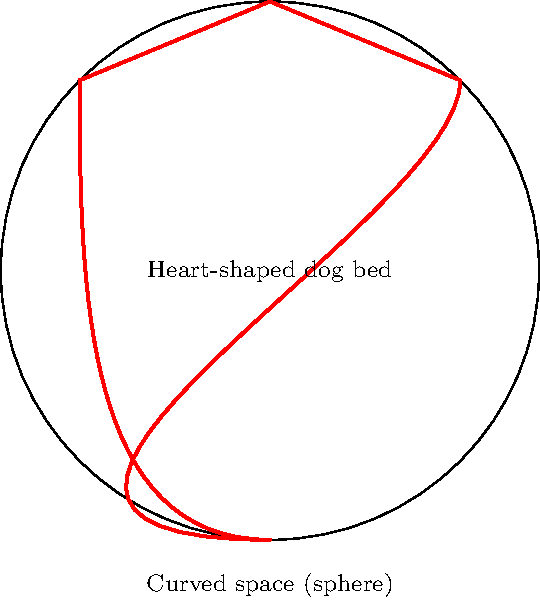On a spherical planet with radius $R$, a heart-shaped dog bed is placed on its surface. The bed's outline is formed by two circular arcs meeting at a point at the top of the heart, and the width of the bed at its widest point is $\frac{\pi R}{2}$. What is the area of this adorable dog bed on the curved surface? Let's approach this step-by-step:

1) In non-Euclidean geometry on a sphere, the area of a shape is proportional to the angle excess of the shape.

2) The heart shape can be divided into two equal parts. Each part is formed by a lune (the area between two great circles) minus a triangle.

3) The width of the bed at its widest point is $\frac{\pi R}{2}$, which means it spans a quarter of the sphere's circumference.

4) The angle at the center of the sphere corresponding to this width is $\frac{\pi}{2}$ radians or 90°.

5) Each lune has an angle of 90°. The area of a lune with angle $\alpha$ on a sphere of radius $R$ is given by $2\alpha R^2$.

6) So, the area of each lune is: $A_{lune} = 2 \cdot \frac{\pi}{2} \cdot R^2 = \pi R^2$

7) The triangle at the bottom of each half of the heart has very small area on the curved surface as its vertices are close together. We can approximate it as having negligible area for this calculation.

8) Therefore, the total area of the heart-shaped dog bed is approximately:

   $A_{heart} \approx 2 \cdot A_{lune} = 2\pi R^2$

9) This is equivalent to half the surface area of the sphere, which makes sense given that the bed spans a quarter of the circumference at its widest point.
Answer: $2\pi R^2$ 